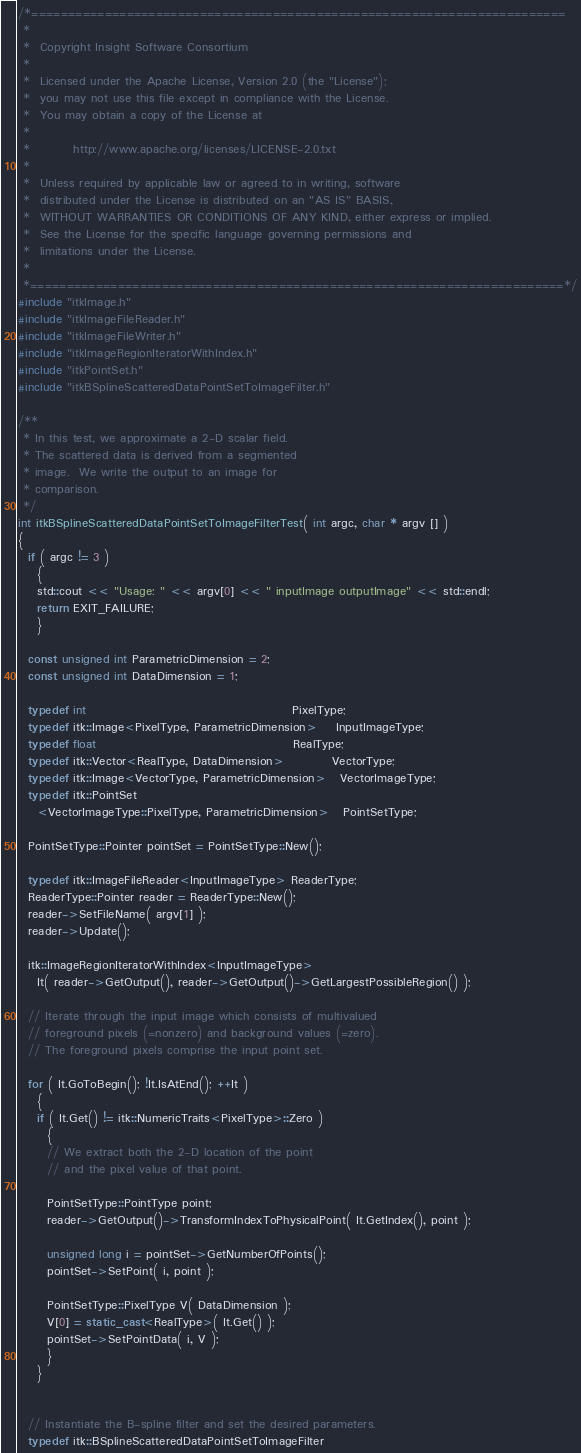<code> <loc_0><loc_0><loc_500><loc_500><_C++_>/*=========================================================================
 *
 *  Copyright Insight Software Consortium
 *
 *  Licensed under the Apache License, Version 2.0 (the "License");
 *  you may not use this file except in compliance with the License.
 *  You may obtain a copy of the License at
 *
 *         http://www.apache.org/licenses/LICENSE-2.0.txt
 *
 *  Unless required by applicable law or agreed to in writing, software
 *  distributed under the License is distributed on an "AS IS" BASIS,
 *  WITHOUT WARRANTIES OR CONDITIONS OF ANY KIND, either express or implied.
 *  See the License for the specific language governing permissions and
 *  limitations under the License.
 *
 *=========================================================================*/
#include "itkImage.h"
#include "itkImageFileReader.h"
#include "itkImageFileWriter.h"
#include "itkImageRegionIteratorWithIndex.h"
#include "itkPointSet.h"
#include "itkBSplineScatteredDataPointSetToImageFilter.h"

/**
 * In this test, we approximate a 2-D scalar field.
 * The scattered data is derived from a segmented
 * image.  We write the output to an image for
 * comparison.
 */
int itkBSplineScatteredDataPointSetToImageFilterTest( int argc, char * argv [] )
{
  if ( argc != 3 )
    {
    std::cout << "Usage: " << argv[0] << " inputImage outputImage" << std::endl;
    return EXIT_FAILURE;
    }

  const unsigned int ParametricDimension = 2;
  const unsigned int DataDimension = 1;

  typedef int                                           PixelType;
  typedef itk::Image<PixelType, ParametricDimension>    InputImageType;
  typedef float                                         RealType;
  typedef itk::Vector<RealType, DataDimension>          VectorType;
  typedef itk::Image<VectorType, ParametricDimension>   VectorImageType;
  typedef itk::PointSet
    <VectorImageType::PixelType, ParametricDimension>   PointSetType;

  PointSetType::Pointer pointSet = PointSetType::New();

  typedef itk::ImageFileReader<InputImageType> ReaderType;
  ReaderType::Pointer reader = ReaderType::New();
  reader->SetFileName( argv[1] );
  reader->Update();

  itk::ImageRegionIteratorWithIndex<InputImageType>
    It( reader->GetOutput(), reader->GetOutput()->GetLargestPossibleRegion() );

  // Iterate through the input image which consists of multivalued
  // foreground pixels (=nonzero) and background values (=zero).
  // The foreground pixels comprise the input point set.

  for ( It.GoToBegin(); !It.IsAtEnd(); ++It )
    {
    if ( It.Get() != itk::NumericTraits<PixelType>::Zero )
      {
      // We extract both the 2-D location of the point
      // and the pixel value of that point.

      PointSetType::PointType point;
      reader->GetOutput()->TransformIndexToPhysicalPoint( It.GetIndex(), point );

      unsigned long i = pointSet->GetNumberOfPoints();
      pointSet->SetPoint( i, point );

      PointSetType::PixelType V( DataDimension );
      V[0] = static_cast<RealType>( It.Get() );
      pointSet->SetPointData( i, V );
      }
    }


  // Instantiate the B-spline filter and set the desired parameters.
  typedef itk::BSplineScatteredDataPointSetToImageFilter</code> 